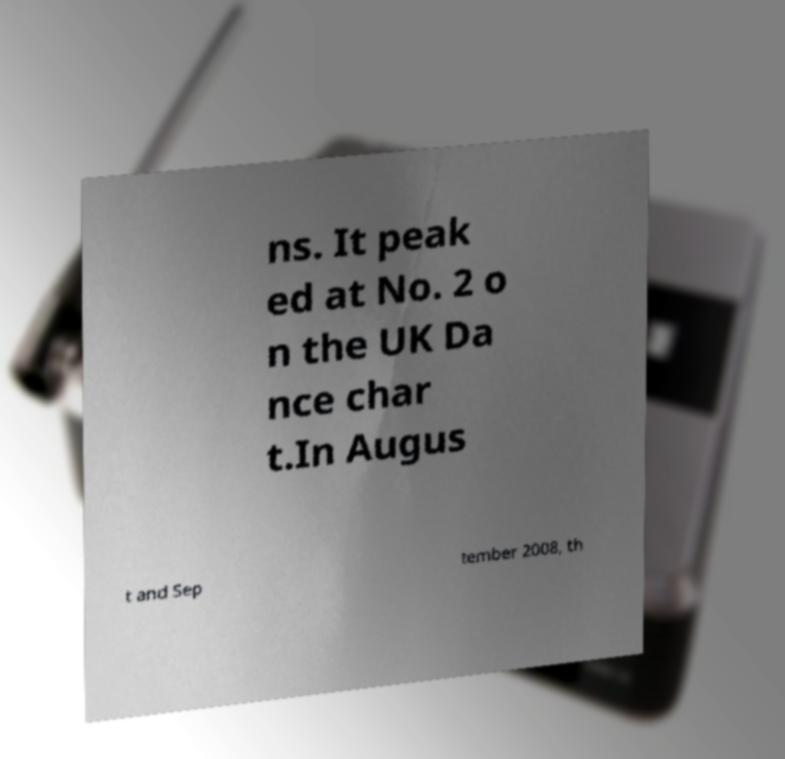I need the written content from this picture converted into text. Can you do that? ns. It peak ed at No. 2 o n the UK Da nce char t.In Augus t and Sep tember 2008, th 